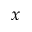<formula> <loc_0><loc_0><loc_500><loc_500>x</formula> 